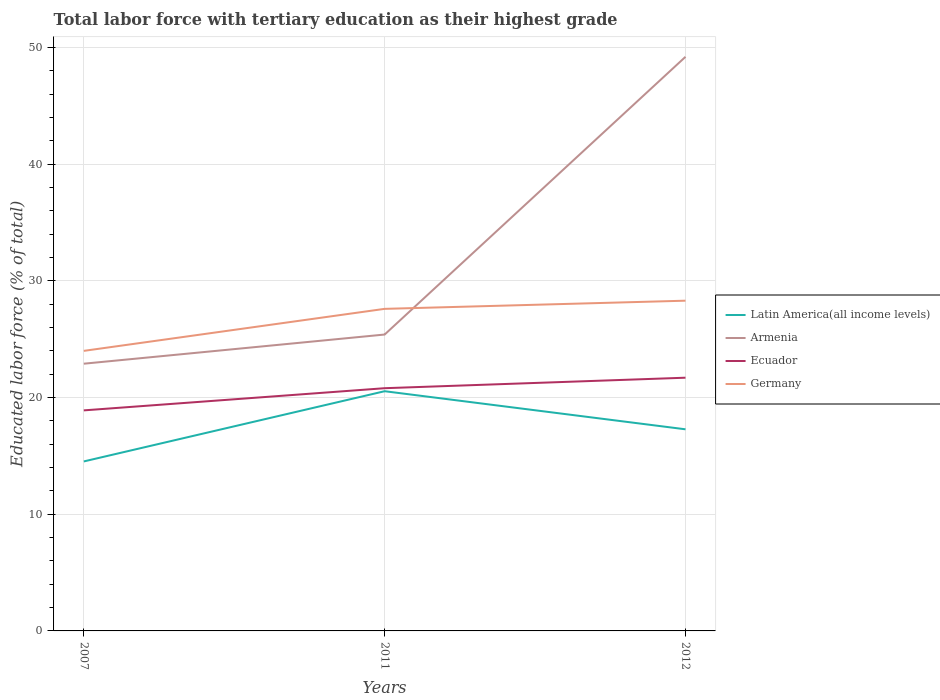How many different coloured lines are there?
Your response must be concise. 4. Does the line corresponding to Ecuador intersect with the line corresponding to Armenia?
Give a very brief answer. No. Is the number of lines equal to the number of legend labels?
Make the answer very short. Yes. Across all years, what is the maximum percentage of male labor force with tertiary education in Armenia?
Your answer should be compact. 22.9. What is the total percentage of male labor force with tertiary education in Germany in the graph?
Make the answer very short. -3.6. What is the difference between the highest and the second highest percentage of male labor force with tertiary education in Latin America(all income levels)?
Give a very brief answer. 6.02. What is the difference between the highest and the lowest percentage of male labor force with tertiary education in Germany?
Provide a short and direct response. 2. How many years are there in the graph?
Ensure brevity in your answer.  3. Are the values on the major ticks of Y-axis written in scientific E-notation?
Provide a short and direct response. No. Does the graph contain any zero values?
Give a very brief answer. No. Where does the legend appear in the graph?
Your answer should be very brief. Center right. What is the title of the graph?
Offer a very short reply. Total labor force with tertiary education as their highest grade. Does "Switzerland" appear as one of the legend labels in the graph?
Make the answer very short. No. What is the label or title of the X-axis?
Your answer should be very brief. Years. What is the label or title of the Y-axis?
Offer a terse response. Educated labor force (% of total). What is the Educated labor force (% of total) of Latin America(all income levels) in 2007?
Make the answer very short. 14.52. What is the Educated labor force (% of total) of Armenia in 2007?
Offer a very short reply. 22.9. What is the Educated labor force (% of total) in Ecuador in 2007?
Keep it short and to the point. 18.9. What is the Educated labor force (% of total) in Germany in 2007?
Ensure brevity in your answer.  24. What is the Educated labor force (% of total) of Latin America(all income levels) in 2011?
Keep it short and to the point. 20.54. What is the Educated labor force (% of total) of Armenia in 2011?
Ensure brevity in your answer.  25.4. What is the Educated labor force (% of total) in Ecuador in 2011?
Your answer should be very brief. 20.8. What is the Educated labor force (% of total) in Germany in 2011?
Keep it short and to the point. 27.6. What is the Educated labor force (% of total) in Latin America(all income levels) in 2012?
Your answer should be very brief. 17.28. What is the Educated labor force (% of total) in Armenia in 2012?
Ensure brevity in your answer.  49.2. What is the Educated labor force (% of total) of Ecuador in 2012?
Provide a succinct answer. 21.7. What is the Educated labor force (% of total) of Germany in 2012?
Offer a terse response. 28.3. Across all years, what is the maximum Educated labor force (% of total) of Latin America(all income levels)?
Offer a very short reply. 20.54. Across all years, what is the maximum Educated labor force (% of total) of Armenia?
Give a very brief answer. 49.2. Across all years, what is the maximum Educated labor force (% of total) of Ecuador?
Ensure brevity in your answer.  21.7. Across all years, what is the maximum Educated labor force (% of total) in Germany?
Ensure brevity in your answer.  28.3. Across all years, what is the minimum Educated labor force (% of total) in Latin America(all income levels)?
Make the answer very short. 14.52. Across all years, what is the minimum Educated labor force (% of total) in Armenia?
Provide a succinct answer. 22.9. Across all years, what is the minimum Educated labor force (% of total) of Ecuador?
Give a very brief answer. 18.9. Across all years, what is the minimum Educated labor force (% of total) in Germany?
Give a very brief answer. 24. What is the total Educated labor force (% of total) of Latin America(all income levels) in the graph?
Your answer should be very brief. 52.34. What is the total Educated labor force (% of total) in Armenia in the graph?
Give a very brief answer. 97.5. What is the total Educated labor force (% of total) in Ecuador in the graph?
Your response must be concise. 61.4. What is the total Educated labor force (% of total) in Germany in the graph?
Provide a succinct answer. 79.9. What is the difference between the Educated labor force (% of total) of Latin America(all income levels) in 2007 and that in 2011?
Provide a short and direct response. -6.02. What is the difference between the Educated labor force (% of total) of Armenia in 2007 and that in 2011?
Offer a terse response. -2.5. What is the difference between the Educated labor force (% of total) of Ecuador in 2007 and that in 2011?
Your answer should be very brief. -1.9. What is the difference between the Educated labor force (% of total) in Germany in 2007 and that in 2011?
Your response must be concise. -3.6. What is the difference between the Educated labor force (% of total) in Latin America(all income levels) in 2007 and that in 2012?
Your response must be concise. -2.75. What is the difference between the Educated labor force (% of total) of Armenia in 2007 and that in 2012?
Your response must be concise. -26.3. What is the difference between the Educated labor force (% of total) of Ecuador in 2007 and that in 2012?
Your answer should be compact. -2.8. What is the difference between the Educated labor force (% of total) of Latin America(all income levels) in 2011 and that in 2012?
Provide a succinct answer. 3.26. What is the difference between the Educated labor force (% of total) in Armenia in 2011 and that in 2012?
Your answer should be very brief. -23.8. What is the difference between the Educated labor force (% of total) in Ecuador in 2011 and that in 2012?
Provide a succinct answer. -0.9. What is the difference between the Educated labor force (% of total) of Germany in 2011 and that in 2012?
Your answer should be very brief. -0.7. What is the difference between the Educated labor force (% of total) of Latin America(all income levels) in 2007 and the Educated labor force (% of total) of Armenia in 2011?
Your answer should be compact. -10.88. What is the difference between the Educated labor force (% of total) of Latin America(all income levels) in 2007 and the Educated labor force (% of total) of Ecuador in 2011?
Give a very brief answer. -6.28. What is the difference between the Educated labor force (% of total) in Latin America(all income levels) in 2007 and the Educated labor force (% of total) in Germany in 2011?
Keep it short and to the point. -13.08. What is the difference between the Educated labor force (% of total) of Armenia in 2007 and the Educated labor force (% of total) of Ecuador in 2011?
Make the answer very short. 2.1. What is the difference between the Educated labor force (% of total) in Ecuador in 2007 and the Educated labor force (% of total) in Germany in 2011?
Your response must be concise. -8.7. What is the difference between the Educated labor force (% of total) of Latin America(all income levels) in 2007 and the Educated labor force (% of total) of Armenia in 2012?
Offer a very short reply. -34.68. What is the difference between the Educated labor force (% of total) in Latin America(all income levels) in 2007 and the Educated labor force (% of total) in Ecuador in 2012?
Your answer should be compact. -7.18. What is the difference between the Educated labor force (% of total) of Latin America(all income levels) in 2007 and the Educated labor force (% of total) of Germany in 2012?
Ensure brevity in your answer.  -13.78. What is the difference between the Educated labor force (% of total) of Armenia in 2007 and the Educated labor force (% of total) of Germany in 2012?
Your response must be concise. -5.4. What is the difference between the Educated labor force (% of total) of Ecuador in 2007 and the Educated labor force (% of total) of Germany in 2012?
Your answer should be compact. -9.4. What is the difference between the Educated labor force (% of total) in Latin America(all income levels) in 2011 and the Educated labor force (% of total) in Armenia in 2012?
Your response must be concise. -28.66. What is the difference between the Educated labor force (% of total) in Latin America(all income levels) in 2011 and the Educated labor force (% of total) in Ecuador in 2012?
Offer a terse response. -1.16. What is the difference between the Educated labor force (% of total) of Latin America(all income levels) in 2011 and the Educated labor force (% of total) of Germany in 2012?
Your answer should be compact. -7.76. What is the average Educated labor force (% of total) of Latin America(all income levels) per year?
Provide a succinct answer. 17.45. What is the average Educated labor force (% of total) of Armenia per year?
Your response must be concise. 32.5. What is the average Educated labor force (% of total) in Ecuador per year?
Your answer should be compact. 20.47. What is the average Educated labor force (% of total) in Germany per year?
Your answer should be compact. 26.63. In the year 2007, what is the difference between the Educated labor force (% of total) in Latin America(all income levels) and Educated labor force (% of total) in Armenia?
Offer a very short reply. -8.38. In the year 2007, what is the difference between the Educated labor force (% of total) in Latin America(all income levels) and Educated labor force (% of total) in Ecuador?
Your answer should be very brief. -4.38. In the year 2007, what is the difference between the Educated labor force (% of total) of Latin America(all income levels) and Educated labor force (% of total) of Germany?
Provide a short and direct response. -9.48. In the year 2007, what is the difference between the Educated labor force (% of total) of Armenia and Educated labor force (% of total) of Ecuador?
Your response must be concise. 4. In the year 2011, what is the difference between the Educated labor force (% of total) of Latin America(all income levels) and Educated labor force (% of total) of Armenia?
Give a very brief answer. -4.86. In the year 2011, what is the difference between the Educated labor force (% of total) in Latin America(all income levels) and Educated labor force (% of total) in Ecuador?
Offer a terse response. -0.26. In the year 2011, what is the difference between the Educated labor force (% of total) in Latin America(all income levels) and Educated labor force (% of total) in Germany?
Provide a short and direct response. -7.06. In the year 2011, what is the difference between the Educated labor force (% of total) of Armenia and Educated labor force (% of total) of Ecuador?
Offer a terse response. 4.6. In the year 2011, what is the difference between the Educated labor force (% of total) of Armenia and Educated labor force (% of total) of Germany?
Give a very brief answer. -2.2. In the year 2011, what is the difference between the Educated labor force (% of total) of Ecuador and Educated labor force (% of total) of Germany?
Provide a succinct answer. -6.8. In the year 2012, what is the difference between the Educated labor force (% of total) of Latin America(all income levels) and Educated labor force (% of total) of Armenia?
Ensure brevity in your answer.  -31.92. In the year 2012, what is the difference between the Educated labor force (% of total) of Latin America(all income levels) and Educated labor force (% of total) of Ecuador?
Ensure brevity in your answer.  -4.42. In the year 2012, what is the difference between the Educated labor force (% of total) in Latin America(all income levels) and Educated labor force (% of total) in Germany?
Your response must be concise. -11.02. In the year 2012, what is the difference between the Educated labor force (% of total) in Armenia and Educated labor force (% of total) in Germany?
Make the answer very short. 20.9. In the year 2012, what is the difference between the Educated labor force (% of total) in Ecuador and Educated labor force (% of total) in Germany?
Make the answer very short. -6.6. What is the ratio of the Educated labor force (% of total) of Latin America(all income levels) in 2007 to that in 2011?
Offer a very short reply. 0.71. What is the ratio of the Educated labor force (% of total) of Armenia in 2007 to that in 2011?
Give a very brief answer. 0.9. What is the ratio of the Educated labor force (% of total) in Ecuador in 2007 to that in 2011?
Keep it short and to the point. 0.91. What is the ratio of the Educated labor force (% of total) in Germany in 2007 to that in 2011?
Give a very brief answer. 0.87. What is the ratio of the Educated labor force (% of total) in Latin America(all income levels) in 2007 to that in 2012?
Give a very brief answer. 0.84. What is the ratio of the Educated labor force (% of total) in Armenia in 2007 to that in 2012?
Provide a short and direct response. 0.47. What is the ratio of the Educated labor force (% of total) of Ecuador in 2007 to that in 2012?
Make the answer very short. 0.87. What is the ratio of the Educated labor force (% of total) of Germany in 2007 to that in 2012?
Your answer should be compact. 0.85. What is the ratio of the Educated labor force (% of total) of Latin America(all income levels) in 2011 to that in 2012?
Provide a short and direct response. 1.19. What is the ratio of the Educated labor force (% of total) in Armenia in 2011 to that in 2012?
Your answer should be very brief. 0.52. What is the ratio of the Educated labor force (% of total) of Ecuador in 2011 to that in 2012?
Ensure brevity in your answer.  0.96. What is the ratio of the Educated labor force (% of total) in Germany in 2011 to that in 2012?
Provide a succinct answer. 0.98. What is the difference between the highest and the second highest Educated labor force (% of total) of Latin America(all income levels)?
Offer a very short reply. 3.26. What is the difference between the highest and the second highest Educated labor force (% of total) of Armenia?
Provide a succinct answer. 23.8. What is the difference between the highest and the second highest Educated labor force (% of total) in Ecuador?
Your answer should be very brief. 0.9. What is the difference between the highest and the second highest Educated labor force (% of total) in Germany?
Your answer should be compact. 0.7. What is the difference between the highest and the lowest Educated labor force (% of total) of Latin America(all income levels)?
Provide a short and direct response. 6.02. What is the difference between the highest and the lowest Educated labor force (% of total) of Armenia?
Your answer should be compact. 26.3. What is the difference between the highest and the lowest Educated labor force (% of total) of Ecuador?
Your answer should be very brief. 2.8. What is the difference between the highest and the lowest Educated labor force (% of total) in Germany?
Offer a terse response. 4.3. 